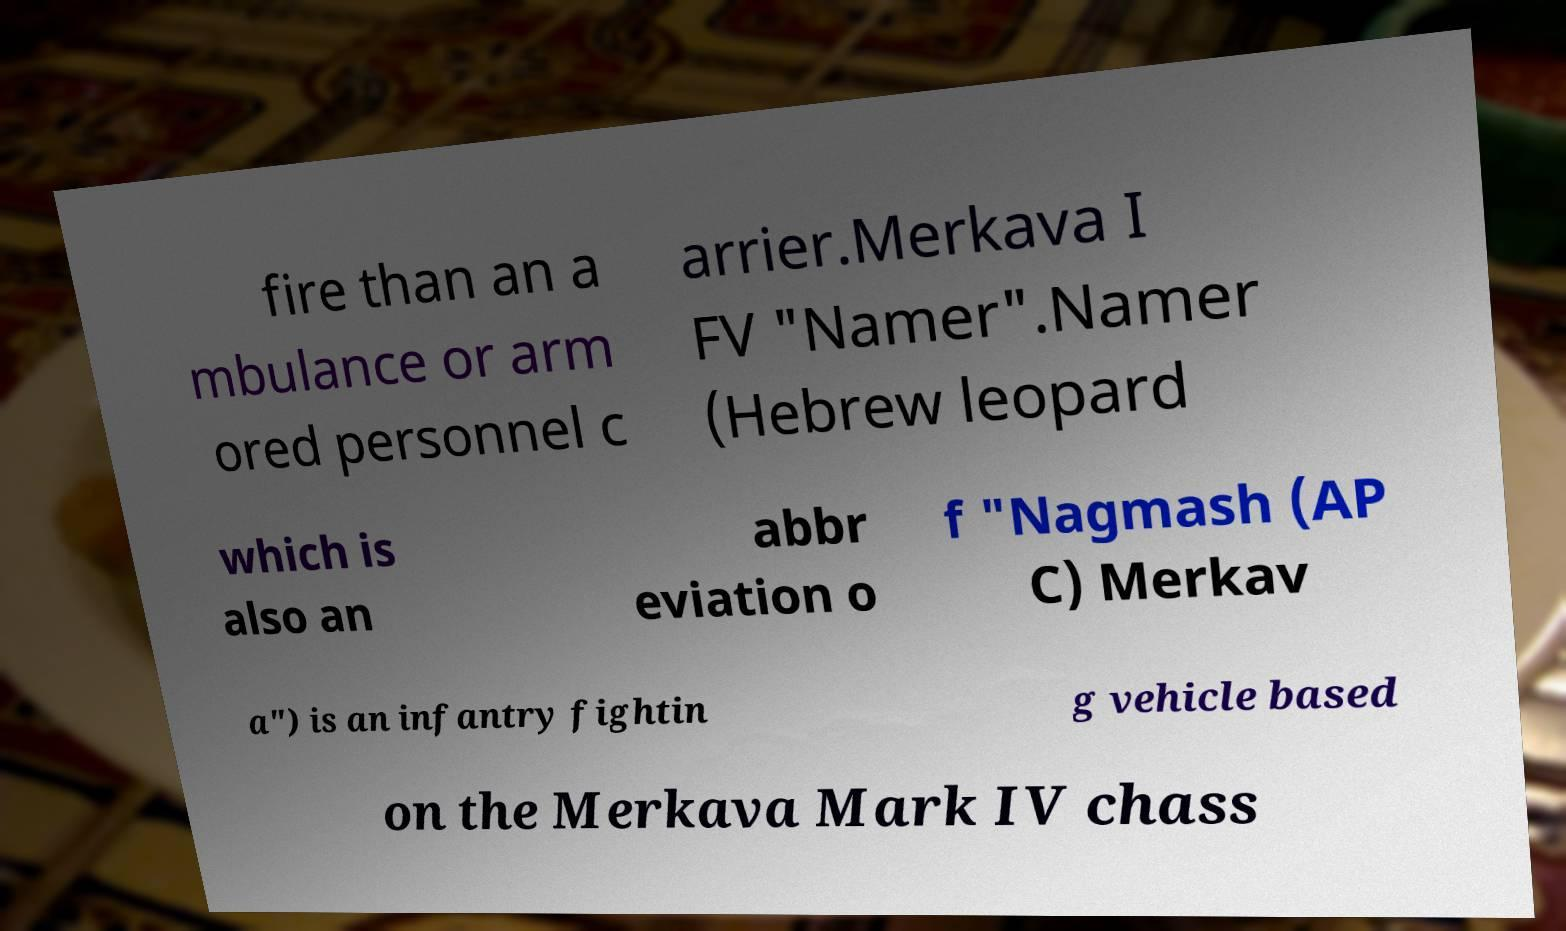What messages or text are displayed in this image? I need them in a readable, typed format. fire than an a mbulance or arm ored personnel c arrier.Merkava I FV "Namer".Namer (Hebrew leopard which is also an abbr eviation o f "Nagmash (AP C) Merkav a") is an infantry fightin g vehicle based on the Merkava Mark IV chass 